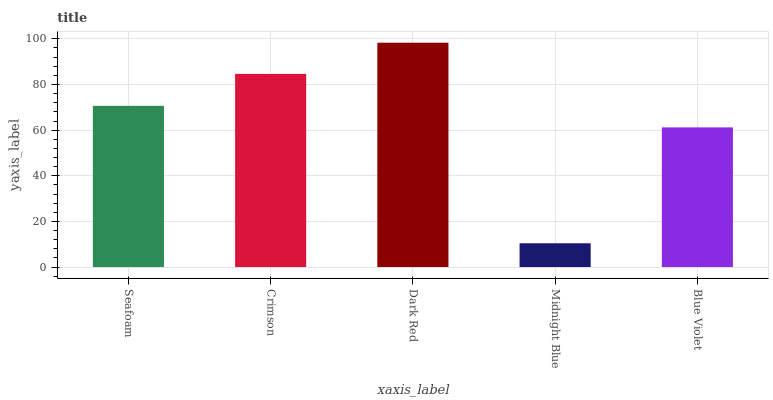Is Midnight Blue the minimum?
Answer yes or no. Yes. Is Dark Red the maximum?
Answer yes or no. Yes. Is Crimson the minimum?
Answer yes or no. No. Is Crimson the maximum?
Answer yes or no. No. Is Crimson greater than Seafoam?
Answer yes or no. Yes. Is Seafoam less than Crimson?
Answer yes or no. Yes. Is Seafoam greater than Crimson?
Answer yes or no. No. Is Crimson less than Seafoam?
Answer yes or no. No. Is Seafoam the high median?
Answer yes or no. Yes. Is Seafoam the low median?
Answer yes or no. Yes. Is Crimson the high median?
Answer yes or no. No. Is Blue Violet the low median?
Answer yes or no. No. 